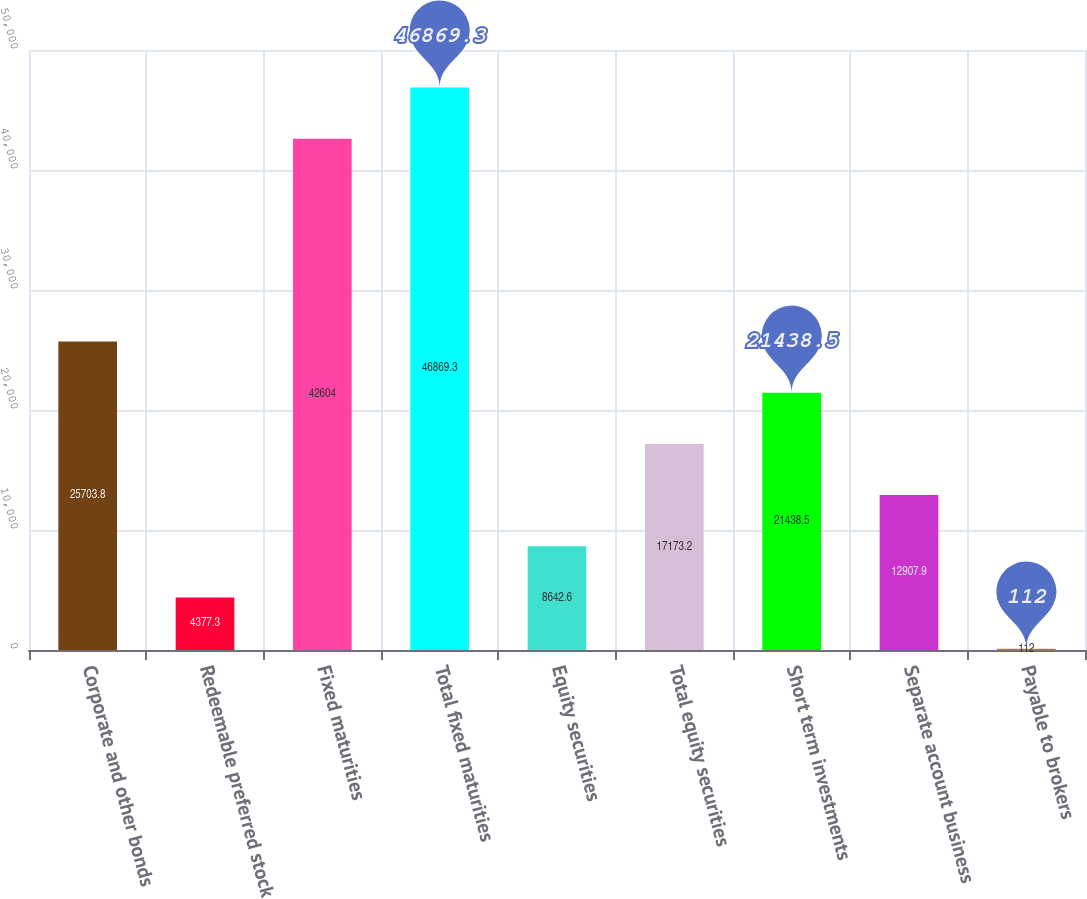<chart> <loc_0><loc_0><loc_500><loc_500><bar_chart><fcel>Corporate and other bonds<fcel>Redeemable preferred stock<fcel>Fixed maturities<fcel>Total fixed maturities<fcel>Equity securities<fcel>Total equity securities<fcel>Short term investments<fcel>Separate account business<fcel>Payable to brokers<nl><fcel>25703.8<fcel>4377.3<fcel>42604<fcel>46869.3<fcel>8642.6<fcel>17173.2<fcel>21438.5<fcel>12907.9<fcel>112<nl></chart> 